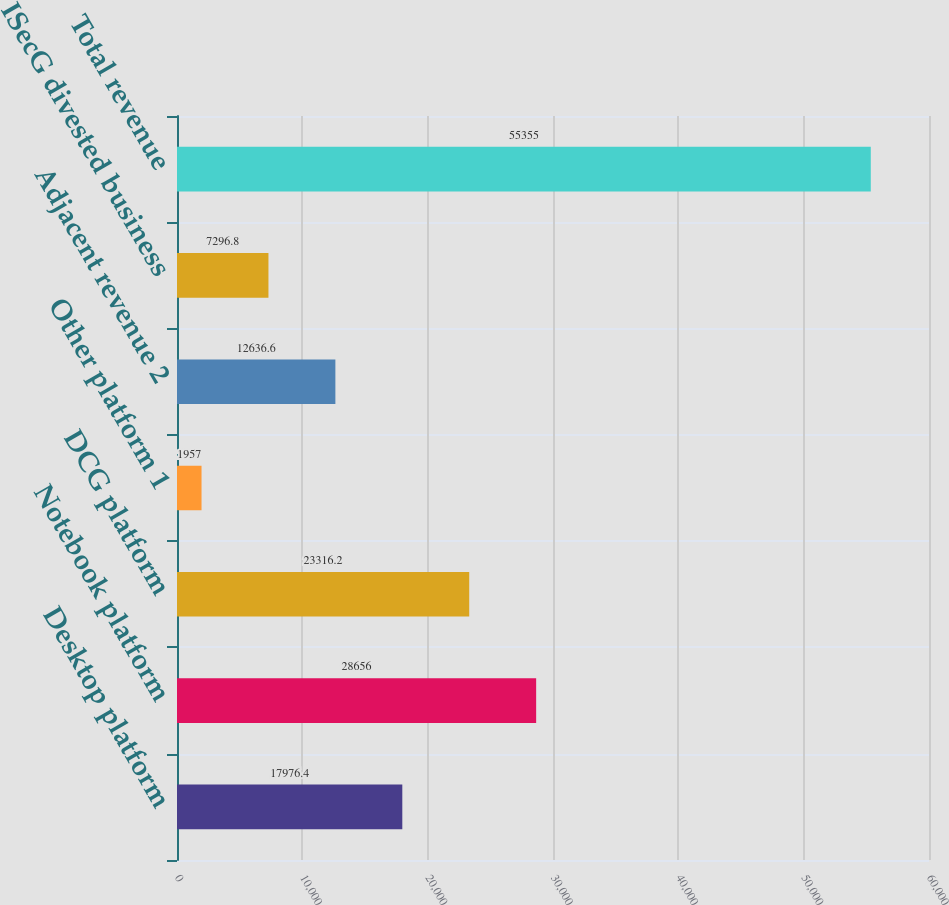<chart> <loc_0><loc_0><loc_500><loc_500><bar_chart><fcel>Desktop platform<fcel>Notebook platform<fcel>DCG platform<fcel>Other platform 1<fcel>Adjacent revenue 2<fcel>ISecG divested business<fcel>Total revenue<nl><fcel>17976.4<fcel>28656<fcel>23316.2<fcel>1957<fcel>12636.6<fcel>7296.8<fcel>55355<nl></chart> 